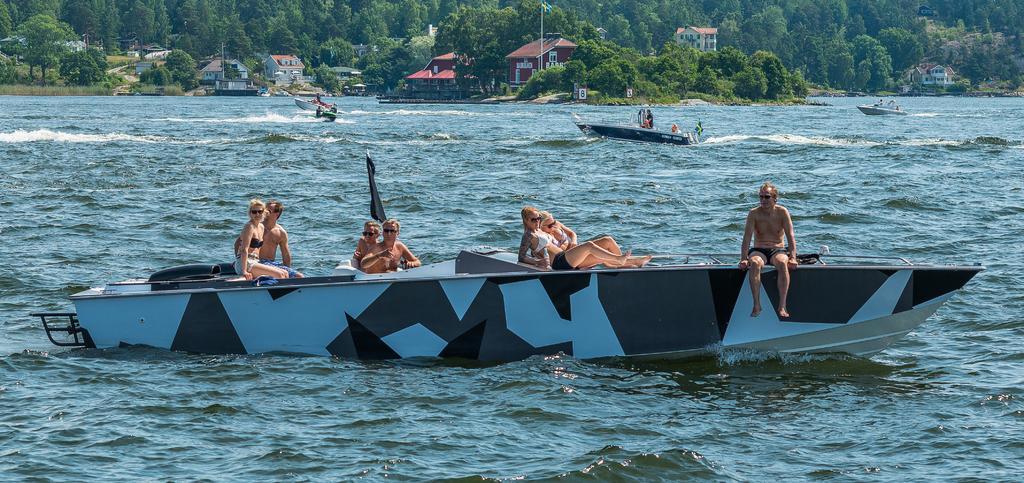Can you describe this image briefly? In the background we can see trees, a flag, houses. In this picture we can see boats, water and people. We can see a black color flag. 